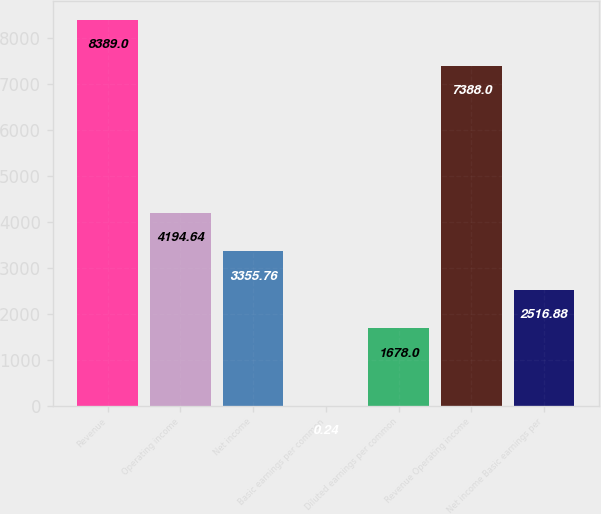<chart> <loc_0><loc_0><loc_500><loc_500><bar_chart><fcel>Revenue<fcel>Operating income<fcel>Net income<fcel>Basic earnings per common<fcel>Diluted earnings per common<fcel>Revenue Operating income<fcel>Net income Basic earnings per<nl><fcel>8389<fcel>4194.64<fcel>3355.76<fcel>0.24<fcel>1678<fcel>7388<fcel>2516.88<nl></chart> 